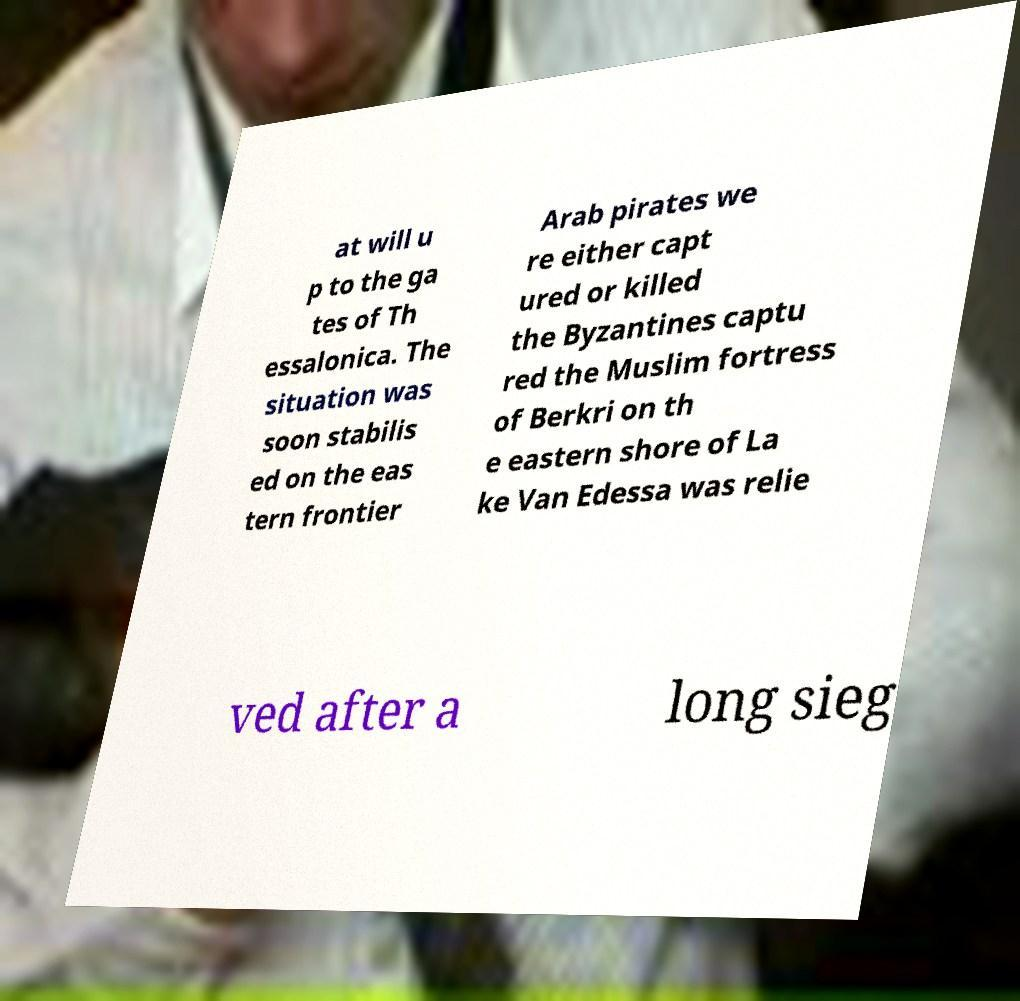Could you extract and type out the text from this image? at will u p to the ga tes of Th essalonica. The situation was soon stabilis ed on the eas tern frontier Arab pirates we re either capt ured or killed the Byzantines captu red the Muslim fortress of Berkri on th e eastern shore of La ke Van Edessa was relie ved after a long sieg 